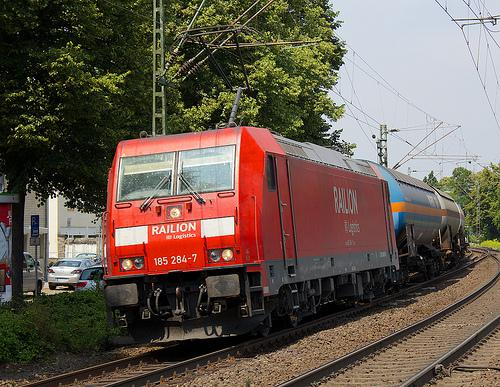Question: what is behind the train?
Choices:
A. Tracks.
B. Trees.
C. The person who missed the train.
D. The cabboose.
Answer with the letter. Answer: B Question: what are parked to the left of the train?
Choices:
A. Vehicles.
B. The trains being repaired.
C. Bicycles.
D. Motorcycles.
Answer with the letter. Answer: A Question: how many sets of train tracks are there?
Choices:
A. Four.
B. Two.
C. Six.
D. Eight.
Answer with the letter. Answer: B 